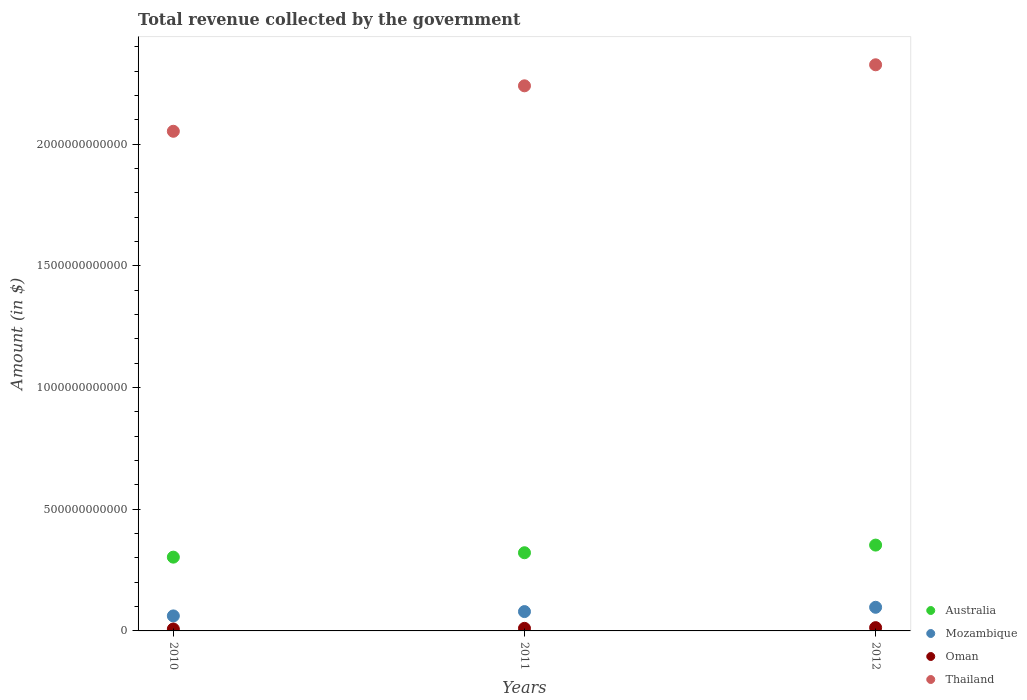How many different coloured dotlines are there?
Give a very brief answer. 4. What is the total revenue collected by the government in Mozambique in 2012?
Your answer should be compact. 9.71e+1. Across all years, what is the maximum total revenue collected by the government in Oman?
Keep it short and to the point. 1.34e+1. Across all years, what is the minimum total revenue collected by the government in Thailand?
Make the answer very short. 2.05e+12. What is the total total revenue collected by the government in Oman in the graph?
Your answer should be compact. 3.19e+1. What is the difference between the total revenue collected by the government in Oman in 2010 and that in 2012?
Give a very brief answer. -5.58e+09. What is the difference between the total revenue collected by the government in Australia in 2011 and the total revenue collected by the government in Mozambique in 2012?
Provide a succinct answer. 2.24e+11. What is the average total revenue collected by the government in Australia per year?
Your answer should be compact. 3.26e+11. In the year 2010, what is the difference between the total revenue collected by the government in Australia and total revenue collected by the government in Mozambique?
Keep it short and to the point. 2.42e+11. What is the ratio of the total revenue collected by the government in Mozambique in 2010 to that in 2011?
Your response must be concise. 0.78. Is the total revenue collected by the government in Oman in 2010 less than that in 2012?
Offer a terse response. Yes. Is the difference between the total revenue collected by the government in Australia in 2010 and 2012 greater than the difference between the total revenue collected by the government in Mozambique in 2010 and 2012?
Ensure brevity in your answer.  No. What is the difference between the highest and the second highest total revenue collected by the government in Mozambique?
Give a very brief answer. 1.77e+1. What is the difference between the highest and the lowest total revenue collected by the government in Mozambique?
Keep it short and to the point. 3.54e+1. In how many years, is the total revenue collected by the government in Mozambique greater than the average total revenue collected by the government in Mozambique taken over all years?
Offer a very short reply. 2. Is the sum of the total revenue collected by the government in Mozambique in 2010 and 2012 greater than the maximum total revenue collected by the government in Australia across all years?
Keep it short and to the point. No. Is it the case that in every year, the sum of the total revenue collected by the government in Mozambique and total revenue collected by the government in Oman  is greater than the sum of total revenue collected by the government in Thailand and total revenue collected by the government in Australia?
Ensure brevity in your answer.  No. Does the total revenue collected by the government in Australia monotonically increase over the years?
Offer a very short reply. Yes. Is the total revenue collected by the government in Australia strictly less than the total revenue collected by the government in Mozambique over the years?
Offer a terse response. No. How many dotlines are there?
Your response must be concise. 4. How many years are there in the graph?
Your answer should be compact. 3. What is the difference between two consecutive major ticks on the Y-axis?
Provide a succinct answer. 5.00e+11. Are the values on the major ticks of Y-axis written in scientific E-notation?
Ensure brevity in your answer.  No. Does the graph contain any zero values?
Provide a succinct answer. No. Where does the legend appear in the graph?
Provide a short and direct response. Bottom right. How many legend labels are there?
Give a very brief answer. 4. What is the title of the graph?
Offer a terse response. Total revenue collected by the government. What is the label or title of the Y-axis?
Keep it short and to the point. Amount (in $). What is the Amount (in $) of Australia in 2010?
Your answer should be very brief. 3.03e+11. What is the Amount (in $) of Mozambique in 2010?
Ensure brevity in your answer.  6.17e+1. What is the Amount (in $) in Oman in 2010?
Your answer should be compact. 7.87e+09. What is the Amount (in $) of Thailand in 2010?
Provide a short and direct response. 2.05e+12. What is the Amount (in $) in Australia in 2011?
Make the answer very short. 3.21e+11. What is the Amount (in $) of Mozambique in 2011?
Provide a short and direct response. 7.94e+1. What is the Amount (in $) in Oman in 2011?
Give a very brief answer. 1.06e+1. What is the Amount (in $) of Thailand in 2011?
Make the answer very short. 2.24e+12. What is the Amount (in $) of Australia in 2012?
Provide a succinct answer. 3.53e+11. What is the Amount (in $) of Mozambique in 2012?
Ensure brevity in your answer.  9.71e+1. What is the Amount (in $) of Oman in 2012?
Offer a terse response. 1.34e+1. What is the Amount (in $) of Thailand in 2012?
Make the answer very short. 2.33e+12. Across all years, what is the maximum Amount (in $) in Australia?
Make the answer very short. 3.53e+11. Across all years, what is the maximum Amount (in $) in Mozambique?
Ensure brevity in your answer.  9.71e+1. Across all years, what is the maximum Amount (in $) of Oman?
Your answer should be compact. 1.34e+1. Across all years, what is the maximum Amount (in $) in Thailand?
Ensure brevity in your answer.  2.33e+12. Across all years, what is the minimum Amount (in $) in Australia?
Offer a terse response. 3.03e+11. Across all years, what is the minimum Amount (in $) of Mozambique?
Your response must be concise. 6.17e+1. Across all years, what is the minimum Amount (in $) in Oman?
Your answer should be compact. 7.87e+09. Across all years, what is the minimum Amount (in $) in Thailand?
Ensure brevity in your answer.  2.05e+12. What is the total Amount (in $) in Australia in the graph?
Give a very brief answer. 9.77e+11. What is the total Amount (in $) in Mozambique in the graph?
Ensure brevity in your answer.  2.38e+11. What is the total Amount (in $) in Oman in the graph?
Provide a short and direct response. 3.19e+1. What is the total Amount (in $) in Thailand in the graph?
Ensure brevity in your answer.  6.62e+12. What is the difference between the Amount (in $) in Australia in 2010 and that in 2011?
Your answer should be compact. -1.81e+1. What is the difference between the Amount (in $) of Mozambique in 2010 and that in 2011?
Provide a short and direct response. -1.77e+1. What is the difference between the Amount (in $) in Oman in 2010 and that in 2011?
Keep it short and to the point. -2.70e+09. What is the difference between the Amount (in $) in Thailand in 2010 and that in 2011?
Offer a very short reply. -1.87e+11. What is the difference between the Amount (in $) of Australia in 2010 and that in 2012?
Offer a very short reply. -4.95e+1. What is the difference between the Amount (in $) of Mozambique in 2010 and that in 2012?
Make the answer very short. -3.54e+1. What is the difference between the Amount (in $) of Oman in 2010 and that in 2012?
Your answer should be compact. -5.58e+09. What is the difference between the Amount (in $) of Thailand in 2010 and that in 2012?
Keep it short and to the point. -2.73e+11. What is the difference between the Amount (in $) of Australia in 2011 and that in 2012?
Provide a short and direct response. -3.14e+1. What is the difference between the Amount (in $) in Mozambique in 2011 and that in 2012?
Give a very brief answer. -1.77e+1. What is the difference between the Amount (in $) of Oman in 2011 and that in 2012?
Offer a very short reply. -2.88e+09. What is the difference between the Amount (in $) of Thailand in 2011 and that in 2012?
Your answer should be compact. -8.64e+1. What is the difference between the Amount (in $) of Australia in 2010 and the Amount (in $) of Mozambique in 2011?
Offer a very short reply. 2.24e+11. What is the difference between the Amount (in $) of Australia in 2010 and the Amount (in $) of Oman in 2011?
Offer a very short reply. 2.93e+11. What is the difference between the Amount (in $) of Australia in 2010 and the Amount (in $) of Thailand in 2011?
Provide a succinct answer. -1.94e+12. What is the difference between the Amount (in $) in Mozambique in 2010 and the Amount (in $) in Oman in 2011?
Provide a short and direct response. 5.11e+1. What is the difference between the Amount (in $) in Mozambique in 2010 and the Amount (in $) in Thailand in 2011?
Offer a very short reply. -2.18e+12. What is the difference between the Amount (in $) in Oman in 2010 and the Amount (in $) in Thailand in 2011?
Give a very brief answer. -2.23e+12. What is the difference between the Amount (in $) of Australia in 2010 and the Amount (in $) of Mozambique in 2012?
Your answer should be compact. 2.06e+11. What is the difference between the Amount (in $) in Australia in 2010 and the Amount (in $) in Oman in 2012?
Make the answer very short. 2.90e+11. What is the difference between the Amount (in $) of Australia in 2010 and the Amount (in $) of Thailand in 2012?
Your answer should be compact. -2.02e+12. What is the difference between the Amount (in $) in Mozambique in 2010 and the Amount (in $) in Oman in 2012?
Keep it short and to the point. 4.82e+1. What is the difference between the Amount (in $) in Mozambique in 2010 and the Amount (in $) in Thailand in 2012?
Ensure brevity in your answer.  -2.26e+12. What is the difference between the Amount (in $) in Oman in 2010 and the Amount (in $) in Thailand in 2012?
Provide a succinct answer. -2.32e+12. What is the difference between the Amount (in $) of Australia in 2011 and the Amount (in $) of Mozambique in 2012?
Make the answer very short. 2.24e+11. What is the difference between the Amount (in $) in Australia in 2011 and the Amount (in $) in Oman in 2012?
Offer a terse response. 3.08e+11. What is the difference between the Amount (in $) of Australia in 2011 and the Amount (in $) of Thailand in 2012?
Make the answer very short. -2.01e+12. What is the difference between the Amount (in $) of Mozambique in 2011 and the Amount (in $) of Oman in 2012?
Make the answer very short. 6.60e+1. What is the difference between the Amount (in $) in Mozambique in 2011 and the Amount (in $) in Thailand in 2012?
Provide a short and direct response. -2.25e+12. What is the difference between the Amount (in $) of Oman in 2011 and the Amount (in $) of Thailand in 2012?
Offer a very short reply. -2.32e+12. What is the average Amount (in $) in Australia per year?
Your answer should be compact. 3.26e+11. What is the average Amount (in $) of Mozambique per year?
Make the answer very short. 7.94e+1. What is the average Amount (in $) of Oman per year?
Provide a succinct answer. 1.06e+1. What is the average Amount (in $) of Thailand per year?
Keep it short and to the point. 2.21e+12. In the year 2010, what is the difference between the Amount (in $) in Australia and Amount (in $) in Mozambique?
Offer a terse response. 2.42e+11. In the year 2010, what is the difference between the Amount (in $) of Australia and Amount (in $) of Oman?
Keep it short and to the point. 2.95e+11. In the year 2010, what is the difference between the Amount (in $) in Australia and Amount (in $) in Thailand?
Your response must be concise. -1.75e+12. In the year 2010, what is the difference between the Amount (in $) of Mozambique and Amount (in $) of Oman?
Your answer should be compact. 5.38e+1. In the year 2010, what is the difference between the Amount (in $) of Mozambique and Amount (in $) of Thailand?
Offer a very short reply. -1.99e+12. In the year 2010, what is the difference between the Amount (in $) of Oman and Amount (in $) of Thailand?
Provide a short and direct response. -2.05e+12. In the year 2011, what is the difference between the Amount (in $) in Australia and Amount (in $) in Mozambique?
Provide a short and direct response. 2.42e+11. In the year 2011, what is the difference between the Amount (in $) of Australia and Amount (in $) of Oman?
Offer a terse response. 3.11e+11. In the year 2011, what is the difference between the Amount (in $) of Australia and Amount (in $) of Thailand?
Provide a short and direct response. -1.92e+12. In the year 2011, what is the difference between the Amount (in $) in Mozambique and Amount (in $) in Oman?
Provide a short and direct response. 6.89e+1. In the year 2011, what is the difference between the Amount (in $) of Mozambique and Amount (in $) of Thailand?
Keep it short and to the point. -2.16e+12. In the year 2011, what is the difference between the Amount (in $) of Oman and Amount (in $) of Thailand?
Your answer should be very brief. -2.23e+12. In the year 2012, what is the difference between the Amount (in $) in Australia and Amount (in $) in Mozambique?
Provide a short and direct response. 2.56e+11. In the year 2012, what is the difference between the Amount (in $) of Australia and Amount (in $) of Oman?
Your answer should be very brief. 3.39e+11. In the year 2012, what is the difference between the Amount (in $) in Australia and Amount (in $) in Thailand?
Make the answer very short. -1.97e+12. In the year 2012, what is the difference between the Amount (in $) of Mozambique and Amount (in $) of Oman?
Give a very brief answer. 8.37e+1. In the year 2012, what is the difference between the Amount (in $) in Mozambique and Amount (in $) in Thailand?
Your answer should be compact. -2.23e+12. In the year 2012, what is the difference between the Amount (in $) of Oman and Amount (in $) of Thailand?
Offer a terse response. -2.31e+12. What is the ratio of the Amount (in $) of Australia in 2010 to that in 2011?
Provide a succinct answer. 0.94. What is the ratio of the Amount (in $) in Mozambique in 2010 to that in 2011?
Provide a succinct answer. 0.78. What is the ratio of the Amount (in $) in Oman in 2010 to that in 2011?
Offer a very short reply. 0.74. What is the ratio of the Amount (in $) of Thailand in 2010 to that in 2011?
Provide a short and direct response. 0.92. What is the ratio of the Amount (in $) of Australia in 2010 to that in 2012?
Your answer should be compact. 0.86. What is the ratio of the Amount (in $) in Mozambique in 2010 to that in 2012?
Keep it short and to the point. 0.64. What is the ratio of the Amount (in $) in Oman in 2010 to that in 2012?
Your answer should be compact. 0.59. What is the ratio of the Amount (in $) of Thailand in 2010 to that in 2012?
Your answer should be very brief. 0.88. What is the ratio of the Amount (in $) in Australia in 2011 to that in 2012?
Your answer should be very brief. 0.91. What is the ratio of the Amount (in $) in Mozambique in 2011 to that in 2012?
Give a very brief answer. 0.82. What is the ratio of the Amount (in $) in Oman in 2011 to that in 2012?
Your answer should be compact. 0.79. What is the ratio of the Amount (in $) in Thailand in 2011 to that in 2012?
Offer a very short reply. 0.96. What is the difference between the highest and the second highest Amount (in $) of Australia?
Provide a succinct answer. 3.14e+1. What is the difference between the highest and the second highest Amount (in $) of Mozambique?
Provide a short and direct response. 1.77e+1. What is the difference between the highest and the second highest Amount (in $) of Oman?
Provide a succinct answer. 2.88e+09. What is the difference between the highest and the second highest Amount (in $) in Thailand?
Keep it short and to the point. 8.64e+1. What is the difference between the highest and the lowest Amount (in $) in Australia?
Provide a succinct answer. 4.95e+1. What is the difference between the highest and the lowest Amount (in $) of Mozambique?
Ensure brevity in your answer.  3.54e+1. What is the difference between the highest and the lowest Amount (in $) in Oman?
Make the answer very short. 5.58e+09. What is the difference between the highest and the lowest Amount (in $) of Thailand?
Offer a terse response. 2.73e+11. 